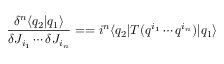Convert formula to latex. <formula><loc_0><loc_0><loc_500><loc_500>\frac { \delta ^ { n } \langle q _ { 2 } | q _ { 1 } \rangle } { \delta J _ { i _ { 1 } } \cdots \delta J _ { i _ { n } } } = = i ^ { n } \langle q _ { 2 } | T ( q ^ { i _ { 1 } } \cdots q ^ { i _ { n } } ) | q _ { 1 } \rangle</formula> 